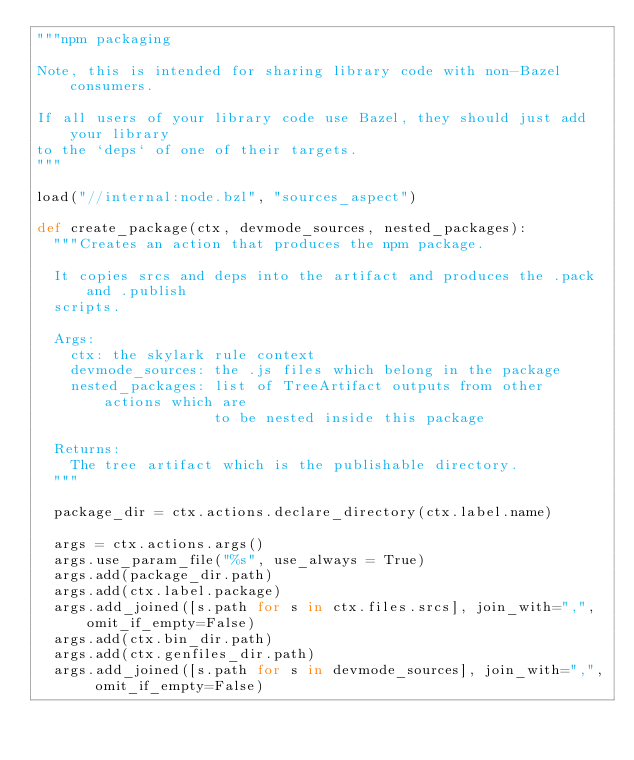Convert code to text. <code><loc_0><loc_0><loc_500><loc_500><_Python_>"""npm packaging

Note, this is intended for sharing library code with non-Bazel consumers.

If all users of your library code use Bazel, they should just add your library
to the `deps` of one of their targets.
"""

load("//internal:node.bzl", "sources_aspect")

def create_package(ctx, devmode_sources, nested_packages):
  """Creates an action that produces the npm package.

  It copies srcs and deps into the artifact and produces the .pack and .publish
  scripts.

  Args:
    ctx: the skylark rule context
    devmode_sources: the .js files which belong in the package
    nested_packages: list of TreeArtifact outputs from other actions which are
                     to be nested inside this package

  Returns:
    The tree artifact which is the publishable directory.
  """

  package_dir = ctx.actions.declare_directory(ctx.label.name)

  args = ctx.actions.args()
  args.use_param_file("%s", use_always = True)
  args.add(package_dir.path)
  args.add(ctx.label.package)
  args.add_joined([s.path for s in ctx.files.srcs], join_with=",", omit_if_empty=False)
  args.add(ctx.bin_dir.path)
  args.add(ctx.genfiles_dir.path)
  args.add_joined([s.path for s in devmode_sources], join_with=",", omit_if_empty=False)</code> 